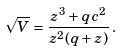<formula> <loc_0><loc_0><loc_500><loc_500>\sqrt { V } = \frac { z ^ { 3 } + q c ^ { 2 } } { z ^ { 2 } ( q + z ) } \, .</formula> 